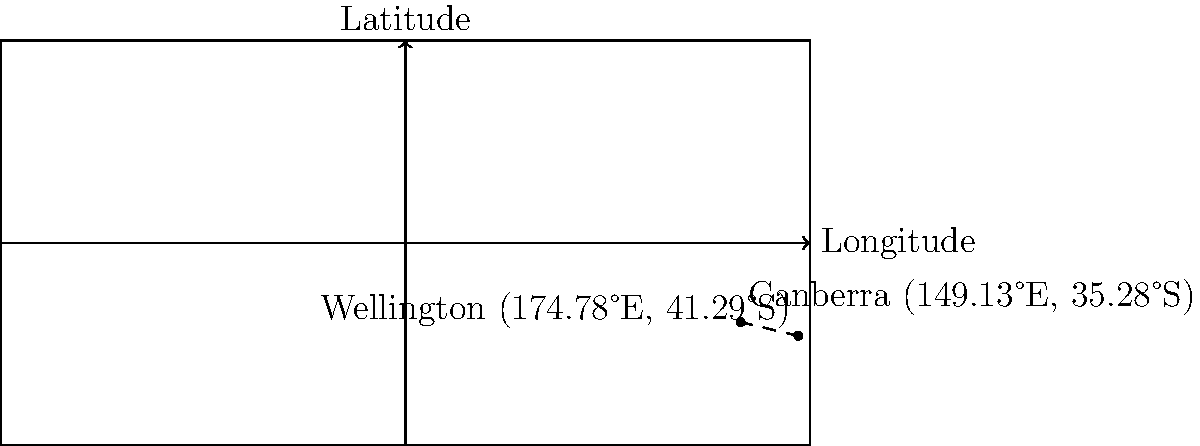As an Australian diplomat fostering strong trans-Tasman relations, you need to calculate the great-circle distance between Canberra and Wellington. Given that Canberra is located at 35.28°S, 149.13°E and Wellington is at 41.29°S, 174.78°E, determine the approximate distance between these two capital cities using the Haversine formula. Express your answer in kilometers, rounded to the nearest whole number. To calculate the great-circle distance between Canberra and Wellington, we'll use the Haversine formula:

1) Convert latitude and longitude to radians:
   Canberra: $\text{lat}_1 = -35.28° \times \frac{\pi}{180} = -0.6158$ rad, $\text{lon}_1 = 149.13° \times \frac{\pi}{180} = 2.6027$ rad
   Wellington: $\text{lat}_2 = -41.29° \times \frac{\pi}{180} = -0.7207$ rad, $\text{lon}_2 = 174.78° \times \frac{\pi}{180} = 3.0508$ rad

2) Calculate the difference in longitude: $\Delta\text{lon} = \text{lon}_2 - \text{lon}_1 = 0.4481$ rad

3) Apply the Haversine formula:
   $a = \sin^2(\frac{\Delta\text{lat}}{2}) + \cos(\text{lat}_1) \times \cos(\text{lat}_2) \times \sin^2(\frac{\Delta\text{lon}}{2})$
   $c = 2 \times \text{atan2}(\sqrt{a}, \sqrt{1-a})$

4) Calculate the distance:
   $d = R \times c$, where $R$ is the Earth's radius (approximately 6,371 km)

5) Plugging in the values:
   $a = \sin^2(\frac{-0.7207 - (-0.6158)}{2}) + \cos(-0.6158) \times \cos(-0.7207) \times \sin^2(\frac{0.4481}{2}) = 0.0043$
   $c = 2 \times \text{atan2}(\sqrt{0.0043}, \sqrt{1-0.0043}) = 0.1310$

6) Distance: $d = 6371 \times 0.1310 = 834.6$ km

7) Rounding to the nearest whole number: 835 km
Answer: 835 km 